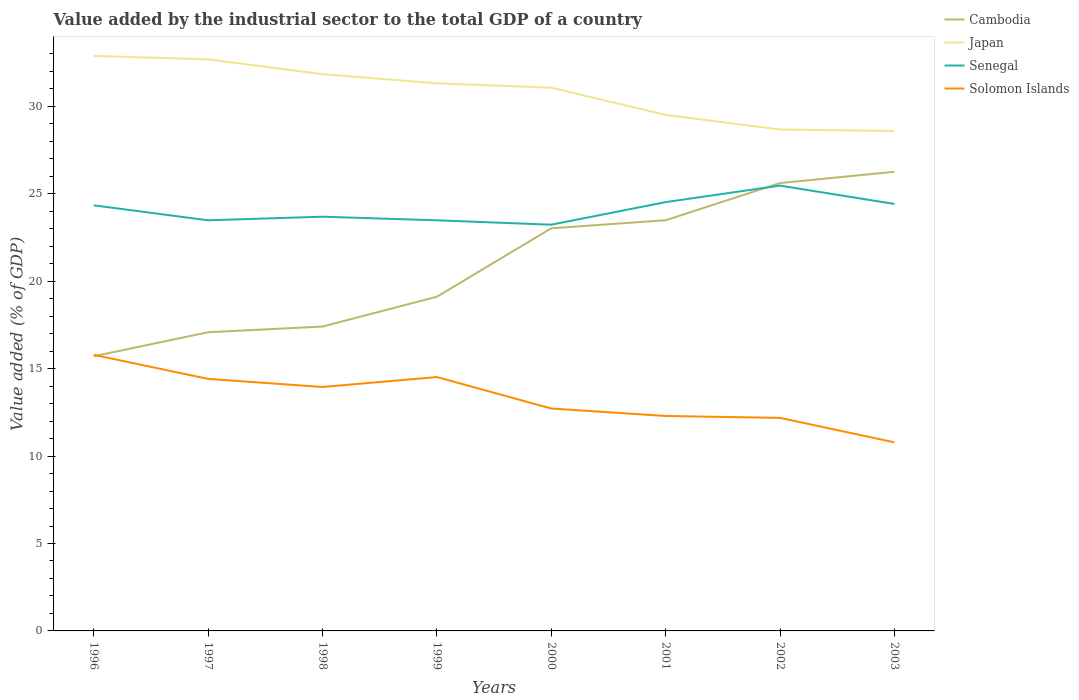How many different coloured lines are there?
Your answer should be very brief. 4. Across all years, what is the maximum value added by the industrial sector to the total GDP in Senegal?
Offer a very short reply. 23.23. In which year was the value added by the industrial sector to the total GDP in Solomon Islands maximum?
Ensure brevity in your answer.  2003. What is the total value added by the industrial sector to the total GDP in Senegal in the graph?
Offer a terse response. 0.25. What is the difference between the highest and the second highest value added by the industrial sector to the total GDP in Cambodia?
Provide a short and direct response. 10.55. Is the value added by the industrial sector to the total GDP in Solomon Islands strictly greater than the value added by the industrial sector to the total GDP in Cambodia over the years?
Offer a terse response. No. How many lines are there?
Your response must be concise. 4. How many years are there in the graph?
Keep it short and to the point. 8. Does the graph contain any zero values?
Provide a short and direct response. No. Does the graph contain grids?
Your response must be concise. No. Where does the legend appear in the graph?
Keep it short and to the point. Top right. How many legend labels are there?
Make the answer very short. 4. What is the title of the graph?
Provide a short and direct response. Value added by the industrial sector to the total GDP of a country. What is the label or title of the X-axis?
Your answer should be compact. Years. What is the label or title of the Y-axis?
Keep it short and to the point. Value added (% of GDP). What is the Value added (% of GDP) of Cambodia in 1996?
Provide a succinct answer. 15.71. What is the Value added (% of GDP) of Japan in 1996?
Your response must be concise. 32.88. What is the Value added (% of GDP) in Senegal in 1996?
Your answer should be very brief. 24.34. What is the Value added (% of GDP) in Solomon Islands in 1996?
Your answer should be compact. 15.79. What is the Value added (% of GDP) in Cambodia in 1997?
Provide a short and direct response. 17.08. What is the Value added (% of GDP) in Japan in 1997?
Your response must be concise. 32.69. What is the Value added (% of GDP) in Senegal in 1997?
Your answer should be compact. 23.48. What is the Value added (% of GDP) of Solomon Islands in 1997?
Give a very brief answer. 14.41. What is the Value added (% of GDP) of Cambodia in 1998?
Provide a short and direct response. 17.41. What is the Value added (% of GDP) of Japan in 1998?
Your answer should be very brief. 31.84. What is the Value added (% of GDP) of Senegal in 1998?
Offer a very short reply. 23.69. What is the Value added (% of GDP) in Solomon Islands in 1998?
Make the answer very short. 13.95. What is the Value added (% of GDP) in Cambodia in 1999?
Your response must be concise. 19.11. What is the Value added (% of GDP) in Japan in 1999?
Your answer should be compact. 31.32. What is the Value added (% of GDP) of Senegal in 1999?
Provide a short and direct response. 23.48. What is the Value added (% of GDP) of Solomon Islands in 1999?
Your response must be concise. 14.52. What is the Value added (% of GDP) of Cambodia in 2000?
Offer a very short reply. 23.03. What is the Value added (% of GDP) of Japan in 2000?
Your answer should be very brief. 31.06. What is the Value added (% of GDP) in Senegal in 2000?
Your answer should be compact. 23.23. What is the Value added (% of GDP) of Solomon Islands in 2000?
Your answer should be compact. 12.72. What is the Value added (% of GDP) in Cambodia in 2001?
Your response must be concise. 23.49. What is the Value added (% of GDP) of Japan in 2001?
Provide a short and direct response. 29.51. What is the Value added (% of GDP) of Senegal in 2001?
Ensure brevity in your answer.  24.52. What is the Value added (% of GDP) of Solomon Islands in 2001?
Provide a succinct answer. 12.29. What is the Value added (% of GDP) in Cambodia in 2002?
Make the answer very short. 25.61. What is the Value added (% of GDP) of Japan in 2002?
Your answer should be compact. 28.67. What is the Value added (% of GDP) of Senegal in 2002?
Keep it short and to the point. 25.47. What is the Value added (% of GDP) in Solomon Islands in 2002?
Provide a succinct answer. 12.18. What is the Value added (% of GDP) in Cambodia in 2003?
Make the answer very short. 26.26. What is the Value added (% of GDP) in Japan in 2003?
Give a very brief answer. 28.59. What is the Value added (% of GDP) in Senegal in 2003?
Your response must be concise. 24.42. What is the Value added (% of GDP) in Solomon Islands in 2003?
Your answer should be very brief. 10.78. Across all years, what is the maximum Value added (% of GDP) in Cambodia?
Provide a succinct answer. 26.26. Across all years, what is the maximum Value added (% of GDP) in Japan?
Give a very brief answer. 32.88. Across all years, what is the maximum Value added (% of GDP) in Senegal?
Your answer should be compact. 25.47. Across all years, what is the maximum Value added (% of GDP) in Solomon Islands?
Your response must be concise. 15.79. Across all years, what is the minimum Value added (% of GDP) in Cambodia?
Provide a succinct answer. 15.71. Across all years, what is the minimum Value added (% of GDP) in Japan?
Ensure brevity in your answer.  28.59. Across all years, what is the minimum Value added (% of GDP) of Senegal?
Ensure brevity in your answer.  23.23. Across all years, what is the minimum Value added (% of GDP) of Solomon Islands?
Give a very brief answer. 10.78. What is the total Value added (% of GDP) of Cambodia in the graph?
Provide a succinct answer. 167.69. What is the total Value added (% of GDP) in Japan in the graph?
Offer a very short reply. 246.57. What is the total Value added (% of GDP) of Senegal in the graph?
Provide a short and direct response. 192.63. What is the total Value added (% of GDP) in Solomon Islands in the graph?
Offer a very short reply. 106.65. What is the difference between the Value added (% of GDP) of Cambodia in 1996 and that in 1997?
Offer a very short reply. -1.38. What is the difference between the Value added (% of GDP) of Japan in 1996 and that in 1997?
Provide a succinct answer. 0.2. What is the difference between the Value added (% of GDP) of Senegal in 1996 and that in 1997?
Keep it short and to the point. 0.86. What is the difference between the Value added (% of GDP) in Solomon Islands in 1996 and that in 1997?
Make the answer very short. 1.37. What is the difference between the Value added (% of GDP) in Cambodia in 1996 and that in 1998?
Keep it short and to the point. -1.7. What is the difference between the Value added (% of GDP) in Japan in 1996 and that in 1998?
Offer a very short reply. 1.05. What is the difference between the Value added (% of GDP) in Senegal in 1996 and that in 1998?
Offer a very short reply. 0.65. What is the difference between the Value added (% of GDP) in Solomon Islands in 1996 and that in 1998?
Offer a very short reply. 1.84. What is the difference between the Value added (% of GDP) of Cambodia in 1996 and that in 1999?
Provide a short and direct response. -3.41. What is the difference between the Value added (% of GDP) in Japan in 1996 and that in 1999?
Provide a succinct answer. 1.57. What is the difference between the Value added (% of GDP) in Senegal in 1996 and that in 1999?
Offer a very short reply. 0.86. What is the difference between the Value added (% of GDP) of Solomon Islands in 1996 and that in 1999?
Offer a terse response. 1.27. What is the difference between the Value added (% of GDP) in Cambodia in 1996 and that in 2000?
Offer a terse response. -7.32. What is the difference between the Value added (% of GDP) of Japan in 1996 and that in 2000?
Offer a very short reply. 1.82. What is the difference between the Value added (% of GDP) in Senegal in 1996 and that in 2000?
Your response must be concise. 1.11. What is the difference between the Value added (% of GDP) of Solomon Islands in 1996 and that in 2000?
Offer a very short reply. 3.07. What is the difference between the Value added (% of GDP) in Cambodia in 1996 and that in 2001?
Give a very brief answer. -7.78. What is the difference between the Value added (% of GDP) in Japan in 1996 and that in 2001?
Your answer should be compact. 3.37. What is the difference between the Value added (% of GDP) in Senegal in 1996 and that in 2001?
Provide a short and direct response. -0.18. What is the difference between the Value added (% of GDP) of Solomon Islands in 1996 and that in 2001?
Your response must be concise. 3.49. What is the difference between the Value added (% of GDP) in Cambodia in 1996 and that in 2002?
Give a very brief answer. -9.91. What is the difference between the Value added (% of GDP) in Japan in 1996 and that in 2002?
Make the answer very short. 4.21. What is the difference between the Value added (% of GDP) in Senegal in 1996 and that in 2002?
Offer a terse response. -1.13. What is the difference between the Value added (% of GDP) in Solomon Islands in 1996 and that in 2002?
Ensure brevity in your answer.  3.6. What is the difference between the Value added (% of GDP) of Cambodia in 1996 and that in 2003?
Your answer should be compact. -10.55. What is the difference between the Value added (% of GDP) in Japan in 1996 and that in 2003?
Your answer should be compact. 4.3. What is the difference between the Value added (% of GDP) of Senegal in 1996 and that in 2003?
Provide a succinct answer. -0.08. What is the difference between the Value added (% of GDP) of Solomon Islands in 1996 and that in 2003?
Your response must be concise. 5. What is the difference between the Value added (% of GDP) in Cambodia in 1997 and that in 1998?
Offer a terse response. -0.32. What is the difference between the Value added (% of GDP) of Japan in 1997 and that in 1998?
Your answer should be very brief. 0.85. What is the difference between the Value added (% of GDP) of Senegal in 1997 and that in 1998?
Ensure brevity in your answer.  -0.21. What is the difference between the Value added (% of GDP) in Solomon Islands in 1997 and that in 1998?
Provide a short and direct response. 0.46. What is the difference between the Value added (% of GDP) of Cambodia in 1997 and that in 1999?
Give a very brief answer. -2.03. What is the difference between the Value added (% of GDP) of Japan in 1997 and that in 1999?
Give a very brief answer. 1.37. What is the difference between the Value added (% of GDP) of Senegal in 1997 and that in 1999?
Offer a very short reply. 0. What is the difference between the Value added (% of GDP) of Solomon Islands in 1997 and that in 1999?
Provide a short and direct response. -0.11. What is the difference between the Value added (% of GDP) in Cambodia in 1997 and that in 2000?
Provide a succinct answer. -5.94. What is the difference between the Value added (% of GDP) in Japan in 1997 and that in 2000?
Your answer should be very brief. 1.62. What is the difference between the Value added (% of GDP) of Senegal in 1997 and that in 2000?
Provide a succinct answer. 0.25. What is the difference between the Value added (% of GDP) in Solomon Islands in 1997 and that in 2000?
Keep it short and to the point. 1.7. What is the difference between the Value added (% of GDP) of Cambodia in 1997 and that in 2001?
Provide a succinct answer. -6.4. What is the difference between the Value added (% of GDP) of Japan in 1997 and that in 2001?
Provide a short and direct response. 3.18. What is the difference between the Value added (% of GDP) in Senegal in 1997 and that in 2001?
Your response must be concise. -1.04. What is the difference between the Value added (% of GDP) in Solomon Islands in 1997 and that in 2001?
Provide a succinct answer. 2.12. What is the difference between the Value added (% of GDP) in Cambodia in 1997 and that in 2002?
Keep it short and to the point. -8.53. What is the difference between the Value added (% of GDP) of Japan in 1997 and that in 2002?
Provide a short and direct response. 4.01. What is the difference between the Value added (% of GDP) in Senegal in 1997 and that in 2002?
Offer a terse response. -1.98. What is the difference between the Value added (% of GDP) in Solomon Islands in 1997 and that in 2002?
Your answer should be compact. 2.23. What is the difference between the Value added (% of GDP) in Cambodia in 1997 and that in 2003?
Provide a succinct answer. -9.18. What is the difference between the Value added (% of GDP) of Japan in 1997 and that in 2003?
Your response must be concise. 4.1. What is the difference between the Value added (% of GDP) of Senegal in 1997 and that in 2003?
Give a very brief answer. -0.93. What is the difference between the Value added (% of GDP) in Solomon Islands in 1997 and that in 2003?
Provide a succinct answer. 3.63. What is the difference between the Value added (% of GDP) of Cambodia in 1998 and that in 1999?
Keep it short and to the point. -1.71. What is the difference between the Value added (% of GDP) in Japan in 1998 and that in 1999?
Your answer should be very brief. 0.52. What is the difference between the Value added (% of GDP) of Senegal in 1998 and that in 1999?
Make the answer very short. 0.21. What is the difference between the Value added (% of GDP) in Solomon Islands in 1998 and that in 1999?
Give a very brief answer. -0.57. What is the difference between the Value added (% of GDP) in Cambodia in 1998 and that in 2000?
Offer a very short reply. -5.62. What is the difference between the Value added (% of GDP) of Japan in 1998 and that in 2000?
Offer a terse response. 0.77. What is the difference between the Value added (% of GDP) of Senegal in 1998 and that in 2000?
Provide a succinct answer. 0.46. What is the difference between the Value added (% of GDP) of Solomon Islands in 1998 and that in 2000?
Your response must be concise. 1.23. What is the difference between the Value added (% of GDP) in Cambodia in 1998 and that in 2001?
Make the answer very short. -6.08. What is the difference between the Value added (% of GDP) in Japan in 1998 and that in 2001?
Keep it short and to the point. 2.33. What is the difference between the Value added (% of GDP) in Senegal in 1998 and that in 2001?
Your answer should be very brief. -0.83. What is the difference between the Value added (% of GDP) in Solomon Islands in 1998 and that in 2001?
Make the answer very short. 1.66. What is the difference between the Value added (% of GDP) of Cambodia in 1998 and that in 2002?
Your response must be concise. -8.21. What is the difference between the Value added (% of GDP) of Japan in 1998 and that in 2002?
Your response must be concise. 3.17. What is the difference between the Value added (% of GDP) of Senegal in 1998 and that in 2002?
Your response must be concise. -1.78. What is the difference between the Value added (% of GDP) of Solomon Islands in 1998 and that in 2002?
Your answer should be compact. 1.77. What is the difference between the Value added (% of GDP) of Cambodia in 1998 and that in 2003?
Provide a short and direct response. -8.85. What is the difference between the Value added (% of GDP) of Japan in 1998 and that in 2003?
Make the answer very short. 3.25. What is the difference between the Value added (% of GDP) of Senegal in 1998 and that in 2003?
Your response must be concise. -0.73. What is the difference between the Value added (% of GDP) of Solomon Islands in 1998 and that in 2003?
Provide a short and direct response. 3.17. What is the difference between the Value added (% of GDP) of Cambodia in 1999 and that in 2000?
Your answer should be very brief. -3.91. What is the difference between the Value added (% of GDP) of Japan in 1999 and that in 2000?
Keep it short and to the point. 0.25. What is the difference between the Value added (% of GDP) in Senegal in 1999 and that in 2000?
Offer a terse response. 0.25. What is the difference between the Value added (% of GDP) of Solomon Islands in 1999 and that in 2000?
Make the answer very short. 1.8. What is the difference between the Value added (% of GDP) of Cambodia in 1999 and that in 2001?
Your response must be concise. -4.37. What is the difference between the Value added (% of GDP) in Japan in 1999 and that in 2001?
Provide a short and direct response. 1.81. What is the difference between the Value added (% of GDP) in Senegal in 1999 and that in 2001?
Provide a succinct answer. -1.04. What is the difference between the Value added (% of GDP) of Solomon Islands in 1999 and that in 2001?
Provide a short and direct response. 2.23. What is the difference between the Value added (% of GDP) in Cambodia in 1999 and that in 2002?
Offer a terse response. -6.5. What is the difference between the Value added (% of GDP) of Japan in 1999 and that in 2002?
Make the answer very short. 2.64. What is the difference between the Value added (% of GDP) in Senegal in 1999 and that in 2002?
Make the answer very short. -1.99. What is the difference between the Value added (% of GDP) in Solomon Islands in 1999 and that in 2002?
Your response must be concise. 2.33. What is the difference between the Value added (% of GDP) in Cambodia in 1999 and that in 2003?
Your answer should be very brief. -7.15. What is the difference between the Value added (% of GDP) in Japan in 1999 and that in 2003?
Your answer should be very brief. 2.73. What is the difference between the Value added (% of GDP) of Senegal in 1999 and that in 2003?
Offer a terse response. -0.93. What is the difference between the Value added (% of GDP) of Solomon Islands in 1999 and that in 2003?
Provide a short and direct response. 3.74. What is the difference between the Value added (% of GDP) in Cambodia in 2000 and that in 2001?
Your response must be concise. -0.46. What is the difference between the Value added (% of GDP) in Japan in 2000 and that in 2001?
Provide a succinct answer. 1.55. What is the difference between the Value added (% of GDP) of Senegal in 2000 and that in 2001?
Your response must be concise. -1.29. What is the difference between the Value added (% of GDP) in Solomon Islands in 2000 and that in 2001?
Your answer should be compact. 0.42. What is the difference between the Value added (% of GDP) in Cambodia in 2000 and that in 2002?
Make the answer very short. -2.59. What is the difference between the Value added (% of GDP) in Japan in 2000 and that in 2002?
Provide a succinct answer. 2.39. What is the difference between the Value added (% of GDP) in Senegal in 2000 and that in 2002?
Give a very brief answer. -2.24. What is the difference between the Value added (% of GDP) of Solomon Islands in 2000 and that in 2002?
Keep it short and to the point. 0.53. What is the difference between the Value added (% of GDP) in Cambodia in 2000 and that in 2003?
Your answer should be very brief. -3.23. What is the difference between the Value added (% of GDP) in Japan in 2000 and that in 2003?
Offer a terse response. 2.48. What is the difference between the Value added (% of GDP) of Senegal in 2000 and that in 2003?
Provide a succinct answer. -1.18. What is the difference between the Value added (% of GDP) in Solomon Islands in 2000 and that in 2003?
Your response must be concise. 1.93. What is the difference between the Value added (% of GDP) in Cambodia in 2001 and that in 2002?
Ensure brevity in your answer.  -2.13. What is the difference between the Value added (% of GDP) of Japan in 2001 and that in 2002?
Make the answer very short. 0.84. What is the difference between the Value added (% of GDP) of Senegal in 2001 and that in 2002?
Keep it short and to the point. -0.94. What is the difference between the Value added (% of GDP) of Solomon Islands in 2001 and that in 2002?
Provide a short and direct response. 0.11. What is the difference between the Value added (% of GDP) of Cambodia in 2001 and that in 2003?
Ensure brevity in your answer.  -2.77. What is the difference between the Value added (% of GDP) in Japan in 2001 and that in 2003?
Offer a terse response. 0.92. What is the difference between the Value added (% of GDP) of Senegal in 2001 and that in 2003?
Make the answer very short. 0.11. What is the difference between the Value added (% of GDP) in Solomon Islands in 2001 and that in 2003?
Your response must be concise. 1.51. What is the difference between the Value added (% of GDP) in Cambodia in 2002 and that in 2003?
Your response must be concise. -0.65. What is the difference between the Value added (% of GDP) in Japan in 2002 and that in 2003?
Offer a terse response. 0.08. What is the difference between the Value added (% of GDP) of Senegal in 2002 and that in 2003?
Provide a short and direct response. 1.05. What is the difference between the Value added (% of GDP) of Solomon Islands in 2002 and that in 2003?
Make the answer very short. 1.4. What is the difference between the Value added (% of GDP) in Cambodia in 1996 and the Value added (% of GDP) in Japan in 1997?
Your answer should be very brief. -16.98. What is the difference between the Value added (% of GDP) of Cambodia in 1996 and the Value added (% of GDP) of Senegal in 1997?
Give a very brief answer. -7.78. What is the difference between the Value added (% of GDP) of Cambodia in 1996 and the Value added (% of GDP) of Solomon Islands in 1997?
Your response must be concise. 1.29. What is the difference between the Value added (% of GDP) in Japan in 1996 and the Value added (% of GDP) in Senegal in 1997?
Give a very brief answer. 9.4. What is the difference between the Value added (% of GDP) of Japan in 1996 and the Value added (% of GDP) of Solomon Islands in 1997?
Offer a very short reply. 18.47. What is the difference between the Value added (% of GDP) of Senegal in 1996 and the Value added (% of GDP) of Solomon Islands in 1997?
Provide a short and direct response. 9.93. What is the difference between the Value added (% of GDP) in Cambodia in 1996 and the Value added (% of GDP) in Japan in 1998?
Offer a very short reply. -16.13. What is the difference between the Value added (% of GDP) of Cambodia in 1996 and the Value added (% of GDP) of Senegal in 1998?
Your answer should be compact. -7.98. What is the difference between the Value added (% of GDP) of Cambodia in 1996 and the Value added (% of GDP) of Solomon Islands in 1998?
Provide a short and direct response. 1.76. What is the difference between the Value added (% of GDP) of Japan in 1996 and the Value added (% of GDP) of Senegal in 1998?
Provide a short and direct response. 9.2. What is the difference between the Value added (% of GDP) in Japan in 1996 and the Value added (% of GDP) in Solomon Islands in 1998?
Offer a terse response. 18.93. What is the difference between the Value added (% of GDP) of Senegal in 1996 and the Value added (% of GDP) of Solomon Islands in 1998?
Give a very brief answer. 10.39. What is the difference between the Value added (% of GDP) in Cambodia in 1996 and the Value added (% of GDP) in Japan in 1999?
Your answer should be very brief. -15.61. What is the difference between the Value added (% of GDP) in Cambodia in 1996 and the Value added (% of GDP) in Senegal in 1999?
Make the answer very short. -7.78. What is the difference between the Value added (% of GDP) in Cambodia in 1996 and the Value added (% of GDP) in Solomon Islands in 1999?
Ensure brevity in your answer.  1.19. What is the difference between the Value added (% of GDP) of Japan in 1996 and the Value added (% of GDP) of Senegal in 1999?
Your answer should be compact. 9.4. What is the difference between the Value added (% of GDP) of Japan in 1996 and the Value added (% of GDP) of Solomon Islands in 1999?
Provide a succinct answer. 18.37. What is the difference between the Value added (% of GDP) of Senegal in 1996 and the Value added (% of GDP) of Solomon Islands in 1999?
Offer a very short reply. 9.82. What is the difference between the Value added (% of GDP) of Cambodia in 1996 and the Value added (% of GDP) of Japan in 2000?
Keep it short and to the point. -15.36. What is the difference between the Value added (% of GDP) in Cambodia in 1996 and the Value added (% of GDP) in Senegal in 2000?
Your answer should be compact. -7.53. What is the difference between the Value added (% of GDP) of Cambodia in 1996 and the Value added (% of GDP) of Solomon Islands in 2000?
Offer a terse response. 2.99. What is the difference between the Value added (% of GDP) of Japan in 1996 and the Value added (% of GDP) of Senegal in 2000?
Ensure brevity in your answer.  9.65. What is the difference between the Value added (% of GDP) of Japan in 1996 and the Value added (% of GDP) of Solomon Islands in 2000?
Provide a short and direct response. 20.17. What is the difference between the Value added (% of GDP) in Senegal in 1996 and the Value added (% of GDP) in Solomon Islands in 2000?
Your response must be concise. 11.62. What is the difference between the Value added (% of GDP) in Cambodia in 1996 and the Value added (% of GDP) in Japan in 2001?
Offer a terse response. -13.8. What is the difference between the Value added (% of GDP) in Cambodia in 1996 and the Value added (% of GDP) in Senegal in 2001?
Provide a short and direct response. -8.82. What is the difference between the Value added (% of GDP) of Cambodia in 1996 and the Value added (% of GDP) of Solomon Islands in 2001?
Make the answer very short. 3.41. What is the difference between the Value added (% of GDP) of Japan in 1996 and the Value added (% of GDP) of Senegal in 2001?
Ensure brevity in your answer.  8.36. What is the difference between the Value added (% of GDP) in Japan in 1996 and the Value added (% of GDP) in Solomon Islands in 2001?
Make the answer very short. 20.59. What is the difference between the Value added (% of GDP) of Senegal in 1996 and the Value added (% of GDP) of Solomon Islands in 2001?
Ensure brevity in your answer.  12.05. What is the difference between the Value added (% of GDP) in Cambodia in 1996 and the Value added (% of GDP) in Japan in 2002?
Give a very brief answer. -12.97. What is the difference between the Value added (% of GDP) of Cambodia in 1996 and the Value added (% of GDP) of Senegal in 2002?
Make the answer very short. -9.76. What is the difference between the Value added (% of GDP) of Cambodia in 1996 and the Value added (% of GDP) of Solomon Islands in 2002?
Provide a short and direct response. 3.52. What is the difference between the Value added (% of GDP) in Japan in 1996 and the Value added (% of GDP) in Senegal in 2002?
Provide a succinct answer. 7.42. What is the difference between the Value added (% of GDP) in Japan in 1996 and the Value added (% of GDP) in Solomon Islands in 2002?
Provide a succinct answer. 20.7. What is the difference between the Value added (% of GDP) of Senegal in 1996 and the Value added (% of GDP) of Solomon Islands in 2002?
Provide a succinct answer. 12.16. What is the difference between the Value added (% of GDP) in Cambodia in 1996 and the Value added (% of GDP) in Japan in 2003?
Give a very brief answer. -12.88. What is the difference between the Value added (% of GDP) of Cambodia in 1996 and the Value added (% of GDP) of Senegal in 2003?
Make the answer very short. -8.71. What is the difference between the Value added (% of GDP) in Cambodia in 1996 and the Value added (% of GDP) in Solomon Islands in 2003?
Make the answer very short. 4.92. What is the difference between the Value added (% of GDP) in Japan in 1996 and the Value added (% of GDP) in Senegal in 2003?
Provide a short and direct response. 8.47. What is the difference between the Value added (% of GDP) of Japan in 1996 and the Value added (% of GDP) of Solomon Islands in 2003?
Your answer should be very brief. 22.1. What is the difference between the Value added (% of GDP) in Senegal in 1996 and the Value added (% of GDP) in Solomon Islands in 2003?
Make the answer very short. 13.56. What is the difference between the Value added (% of GDP) in Cambodia in 1997 and the Value added (% of GDP) in Japan in 1998?
Your answer should be very brief. -14.76. What is the difference between the Value added (% of GDP) in Cambodia in 1997 and the Value added (% of GDP) in Senegal in 1998?
Your response must be concise. -6.61. What is the difference between the Value added (% of GDP) in Cambodia in 1997 and the Value added (% of GDP) in Solomon Islands in 1998?
Offer a terse response. 3.13. What is the difference between the Value added (% of GDP) of Japan in 1997 and the Value added (% of GDP) of Senegal in 1998?
Provide a succinct answer. 9. What is the difference between the Value added (% of GDP) in Japan in 1997 and the Value added (% of GDP) in Solomon Islands in 1998?
Your answer should be very brief. 18.74. What is the difference between the Value added (% of GDP) in Senegal in 1997 and the Value added (% of GDP) in Solomon Islands in 1998?
Keep it short and to the point. 9.53. What is the difference between the Value added (% of GDP) of Cambodia in 1997 and the Value added (% of GDP) of Japan in 1999?
Your answer should be compact. -14.24. What is the difference between the Value added (% of GDP) in Cambodia in 1997 and the Value added (% of GDP) in Senegal in 1999?
Keep it short and to the point. -6.4. What is the difference between the Value added (% of GDP) in Cambodia in 1997 and the Value added (% of GDP) in Solomon Islands in 1999?
Offer a very short reply. 2.56. What is the difference between the Value added (% of GDP) in Japan in 1997 and the Value added (% of GDP) in Senegal in 1999?
Your response must be concise. 9.21. What is the difference between the Value added (% of GDP) in Japan in 1997 and the Value added (% of GDP) in Solomon Islands in 1999?
Keep it short and to the point. 18.17. What is the difference between the Value added (% of GDP) in Senegal in 1997 and the Value added (% of GDP) in Solomon Islands in 1999?
Ensure brevity in your answer.  8.96. What is the difference between the Value added (% of GDP) in Cambodia in 1997 and the Value added (% of GDP) in Japan in 2000?
Give a very brief answer. -13.98. What is the difference between the Value added (% of GDP) of Cambodia in 1997 and the Value added (% of GDP) of Senegal in 2000?
Make the answer very short. -6.15. What is the difference between the Value added (% of GDP) in Cambodia in 1997 and the Value added (% of GDP) in Solomon Islands in 2000?
Give a very brief answer. 4.36. What is the difference between the Value added (% of GDP) of Japan in 1997 and the Value added (% of GDP) of Senegal in 2000?
Offer a very short reply. 9.46. What is the difference between the Value added (% of GDP) in Japan in 1997 and the Value added (% of GDP) in Solomon Islands in 2000?
Your answer should be compact. 19.97. What is the difference between the Value added (% of GDP) of Senegal in 1997 and the Value added (% of GDP) of Solomon Islands in 2000?
Give a very brief answer. 10.76. What is the difference between the Value added (% of GDP) in Cambodia in 1997 and the Value added (% of GDP) in Japan in 2001?
Offer a terse response. -12.43. What is the difference between the Value added (% of GDP) in Cambodia in 1997 and the Value added (% of GDP) in Senegal in 2001?
Provide a short and direct response. -7.44. What is the difference between the Value added (% of GDP) in Cambodia in 1997 and the Value added (% of GDP) in Solomon Islands in 2001?
Your answer should be compact. 4.79. What is the difference between the Value added (% of GDP) of Japan in 1997 and the Value added (% of GDP) of Senegal in 2001?
Your response must be concise. 8.16. What is the difference between the Value added (% of GDP) of Japan in 1997 and the Value added (% of GDP) of Solomon Islands in 2001?
Ensure brevity in your answer.  20.39. What is the difference between the Value added (% of GDP) of Senegal in 1997 and the Value added (% of GDP) of Solomon Islands in 2001?
Ensure brevity in your answer.  11.19. What is the difference between the Value added (% of GDP) in Cambodia in 1997 and the Value added (% of GDP) in Japan in 2002?
Make the answer very short. -11.59. What is the difference between the Value added (% of GDP) in Cambodia in 1997 and the Value added (% of GDP) in Senegal in 2002?
Your answer should be compact. -8.38. What is the difference between the Value added (% of GDP) in Cambodia in 1997 and the Value added (% of GDP) in Solomon Islands in 2002?
Your response must be concise. 4.9. What is the difference between the Value added (% of GDP) of Japan in 1997 and the Value added (% of GDP) of Senegal in 2002?
Ensure brevity in your answer.  7.22. What is the difference between the Value added (% of GDP) of Japan in 1997 and the Value added (% of GDP) of Solomon Islands in 2002?
Keep it short and to the point. 20.5. What is the difference between the Value added (% of GDP) of Senegal in 1997 and the Value added (% of GDP) of Solomon Islands in 2002?
Your answer should be compact. 11.3. What is the difference between the Value added (% of GDP) in Cambodia in 1997 and the Value added (% of GDP) in Japan in 2003?
Your answer should be compact. -11.51. What is the difference between the Value added (% of GDP) of Cambodia in 1997 and the Value added (% of GDP) of Senegal in 2003?
Give a very brief answer. -7.33. What is the difference between the Value added (% of GDP) of Cambodia in 1997 and the Value added (% of GDP) of Solomon Islands in 2003?
Provide a succinct answer. 6.3. What is the difference between the Value added (% of GDP) in Japan in 1997 and the Value added (% of GDP) in Senegal in 2003?
Provide a short and direct response. 8.27. What is the difference between the Value added (% of GDP) of Japan in 1997 and the Value added (% of GDP) of Solomon Islands in 2003?
Provide a succinct answer. 21.9. What is the difference between the Value added (% of GDP) in Senegal in 1997 and the Value added (% of GDP) in Solomon Islands in 2003?
Offer a very short reply. 12.7. What is the difference between the Value added (% of GDP) in Cambodia in 1998 and the Value added (% of GDP) in Japan in 1999?
Your answer should be compact. -13.91. What is the difference between the Value added (% of GDP) in Cambodia in 1998 and the Value added (% of GDP) in Senegal in 1999?
Make the answer very short. -6.08. What is the difference between the Value added (% of GDP) of Cambodia in 1998 and the Value added (% of GDP) of Solomon Islands in 1999?
Make the answer very short. 2.89. What is the difference between the Value added (% of GDP) in Japan in 1998 and the Value added (% of GDP) in Senegal in 1999?
Keep it short and to the point. 8.36. What is the difference between the Value added (% of GDP) of Japan in 1998 and the Value added (% of GDP) of Solomon Islands in 1999?
Your answer should be very brief. 17.32. What is the difference between the Value added (% of GDP) of Senegal in 1998 and the Value added (% of GDP) of Solomon Islands in 1999?
Offer a very short reply. 9.17. What is the difference between the Value added (% of GDP) in Cambodia in 1998 and the Value added (% of GDP) in Japan in 2000?
Your answer should be very brief. -13.66. What is the difference between the Value added (% of GDP) of Cambodia in 1998 and the Value added (% of GDP) of Senegal in 2000?
Your answer should be compact. -5.83. What is the difference between the Value added (% of GDP) in Cambodia in 1998 and the Value added (% of GDP) in Solomon Islands in 2000?
Provide a succinct answer. 4.69. What is the difference between the Value added (% of GDP) in Japan in 1998 and the Value added (% of GDP) in Senegal in 2000?
Your answer should be compact. 8.61. What is the difference between the Value added (% of GDP) in Japan in 1998 and the Value added (% of GDP) in Solomon Islands in 2000?
Provide a succinct answer. 19.12. What is the difference between the Value added (% of GDP) of Senegal in 1998 and the Value added (% of GDP) of Solomon Islands in 2000?
Ensure brevity in your answer.  10.97. What is the difference between the Value added (% of GDP) of Cambodia in 1998 and the Value added (% of GDP) of Japan in 2001?
Your answer should be very brief. -12.1. What is the difference between the Value added (% of GDP) of Cambodia in 1998 and the Value added (% of GDP) of Senegal in 2001?
Ensure brevity in your answer.  -7.12. What is the difference between the Value added (% of GDP) of Cambodia in 1998 and the Value added (% of GDP) of Solomon Islands in 2001?
Offer a very short reply. 5.11. What is the difference between the Value added (% of GDP) in Japan in 1998 and the Value added (% of GDP) in Senegal in 2001?
Keep it short and to the point. 7.32. What is the difference between the Value added (% of GDP) of Japan in 1998 and the Value added (% of GDP) of Solomon Islands in 2001?
Your answer should be very brief. 19.55. What is the difference between the Value added (% of GDP) of Senegal in 1998 and the Value added (% of GDP) of Solomon Islands in 2001?
Your answer should be very brief. 11.4. What is the difference between the Value added (% of GDP) in Cambodia in 1998 and the Value added (% of GDP) in Japan in 2002?
Your answer should be compact. -11.27. What is the difference between the Value added (% of GDP) in Cambodia in 1998 and the Value added (% of GDP) in Senegal in 2002?
Provide a short and direct response. -8.06. What is the difference between the Value added (% of GDP) in Cambodia in 1998 and the Value added (% of GDP) in Solomon Islands in 2002?
Your answer should be very brief. 5.22. What is the difference between the Value added (% of GDP) in Japan in 1998 and the Value added (% of GDP) in Senegal in 2002?
Your response must be concise. 6.37. What is the difference between the Value added (% of GDP) in Japan in 1998 and the Value added (% of GDP) in Solomon Islands in 2002?
Offer a terse response. 19.66. What is the difference between the Value added (% of GDP) in Senegal in 1998 and the Value added (% of GDP) in Solomon Islands in 2002?
Give a very brief answer. 11.5. What is the difference between the Value added (% of GDP) in Cambodia in 1998 and the Value added (% of GDP) in Japan in 2003?
Ensure brevity in your answer.  -11.18. What is the difference between the Value added (% of GDP) of Cambodia in 1998 and the Value added (% of GDP) of Senegal in 2003?
Offer a terse response. -7.01. What is the difference between the Value added (% of GDP) of Cambodia in 1998 and the Value added (% of GDP) of Solomon Islands in 2003?
Offer a terse response. 6.62. What is the difference between the Value added (% of GDP) in Japan in 1998 and the Value added (% of GDP) in Senegal in 2003?
Give a very brief answer. 7.42. What is the difference between the Value added (% of GDP) in Japan in 1998 and the Value added (% of GDP) in Solomon Islands in 2003?
Your response must be concise. 21.06. What is the difference between the Value added (% of GDP) in Senegal in 1998 and the Value added (% of GDP) in Solomon Islands in 2003?
Ensure brevity in your answer.  12.9. What is the difference between the Value added (% of GDP) of Cambodia in 1999 and the Value added (% of GDP) of Japan in 2000?
Make the answer very short. -11.95. What is the difference between the Value added (% of GDP) in Cambodia in 1999 and the Value added (% of GDP) in Senegal in 2000?
Ensure brevity in your answer.  -4.12. What is the difference between the Value added (% of GDP) of Cambodia in 1999 and the Value added (% of GDP) of Solomon Islands in 2000?
Offer a terse response. 6.39. What is the difference between the Value added (% of GDP) in Japan in 1999 and the Value added (% of GDP) in Senegal in 2000?
Provide a succinct answer. 8.09. What is the difference between the Value added (% of GDP) in Japan in 1999 and the Value added (% of GDP) in Solomon Islands in 2000?
Keep it short and to the point. 18.6. What is the difference between the Value added (% of GDP) of Senegal in 1999 and the Value added (% of GDP) of Solomon Islands in 2000?
Provide a succinct answer. 10.76. What is the difference between the Value added (% of GDP) of Cambodia in 1999 and the Value added (% of GDP) of Japan in 2001?
Your answer should be compact. -10.4. What is the difference between the Value added (% of GDP) in Cambodia in 1999 and the Value added (% of GDP) in Senegal in 2001?
Your response must be concise. -5.41. What is the difference between the Value added (% of GDP) of Cambodia in 1999 and the Value added (% of GDP) of Solomon Islands in 2001?
Ensure brevity in your answer.  6.82. What is the difference between the Value added (% of GDP) of Japan in 1999 and the Value added (% of GDP) of Senegal in 2001?
Your response must be concise. 6.8. What is the difference between the Value added (% of GDP) of Japan in 1999 and the Value added (% of GDP) of Solomon Islands in 2001?
Offer a very short reply. 19.03. What is the difference between the Value added (% of GDP) in Senegal in 1999 and the Value added (% of GDP) in Solomon Islands in 2001?
Keep it short and to the point. 11.19. What is the difference between the Value added (% of GDP) in Cambodia in 1999 and the Value added (% of GDP) in Japan in 2002?
Your answer should be very brief. -9.56. What is the difference between the Value added (% of GDP) of Cambodia in 1999 and the Value added (% of GDP) of Senegal in 2002?
Your answer should be very brief. -6.35. What is the difference between the Value added (% of GDP) of Cambodia in 1999 and the Value added (% of GDP) of Solomon Islands in 2002?
Your answer should be very brief. 6.93. What is the difference between the Value added (% of GDP) in Japan in 1999 and the Value added (% of GDP) in Senegal in 2002?
Offer a terse response. 5.85. What is the difference between the Value added (% of GDP) in Japan in 1999 and the Value added (% of GDP) in Solomon Islands in 2002?
Provide a short and direct response. 19.13. What is the difference between the Value added (% of GDP) of Senegal in 1999 and the Value added (% of GDP) of Solomon Islands in 2002?
Your response must be concise. 11.3. What is the difference between the Value added (% of GDP) of Cambodia in 1999 and the Value added (% of GDP) of Japan in 2003?
Your response must be concise. -9.48. What is the difference between the Value added (% of GDP) of Cambodia in 1999 and the Value added (% of GDP) of Senegal in 2003?
Keep it short and to the point. -5.3. What is the difference between the Value added (% of GDP) in Cambodia in 1999 and the Value added (% of GDP) in Solomon Islands in 2003?
Your answer should be very brief. 8.33. What is the difference between the Value added (% of GDP) in Japan in 1999 and the Value added (% of GDP) in Senegal in 2003?
Give a very brief answer. 6.9. What is the difference between the Value added (% of GDP) of Japan in 1999 and the Value added (% of GDP) of Solomon Islands in 2003?
Offer a terse response. 20.53. What is the difference between the Value added (% of GDP) of Senegal in 1999 and the Value added (% of GDP) of Solomon Islands in 2003?
Provide a short and direct response. 12.7. What is the difference between the Value added (% of GDP) in Cambodia in 2000 and the Value added (% of GDP) in Japan in 2001?
Keep it short and to the point. -6.48. What is the difference between the Value added (% of GDP) in Cambodia in 2000 and the Value added (% of GDP) in Senegal in 2001?
Offer a terse response. -1.5. What is the difference between the Value added (% of GDP) in Cambodia in 2000 and the Value added (% of GDP) in Solomon Islands in 2001?
Your answer should be very brief. 10.73. What is the difference between the Value added (% of GDP) of Japan in 2000 and the Value added (% of GDP) of Senegal in 2001?
Offer a terse response. 6.54. What is the difference between the Value added (% of GDP) of Japan in 2000 and the Value added (% of GDP) of Solomon Islands in 2001?
Give a very brief answer. 18.77. What is the difference between the Value added (% of GDP) in Senegal in 2000 and the Value added (% of GDP) in Solomon Islands in 2001?
Make the answer very short. 10.94. What is the difference between the Value added (% of GDP) in Cambodia in 2000 and the Value added (% of GDP) in Japan in 2002?
Provide a succinct answer. -5.65. What is the difference between the Value added (% of GDP) of Cambodia in 2000 and the Value added (% of GDP) of Senegal in 2002?
Your response must be concise. -2.44. What is the difference between the Value added (% of GDP) of Cambodia in 2000 and the Value added (% of GDP) of Solomon Islands in 2002?
Your answer should be very brief. 10.84. What is the difference between the Value added (% of GDP) in Japan in 2000 and the Value added (% of GDP) in Senegal in 2002?
Keep it short and to the point. 5.6. What is the difference between the Value added (% of GDP) of Japan in 2000 and the Value added (% of GDP) of Solomon Islands in 2002?
Provide a short and direct response. 18.88. What is the difference between the Value added (% of GDP) of Senegal in 2000 and the Value added (% of GDP) of Solomon Islands in 2002?
Offer a very short reply. 11.05. What is the difference between the Value added (% of GDP) in Cambodia in 2000 and the Value added (% of GDP) in Japan in 2003?
Provide a succinct answer. -5.56. What is the difference between the Value added (% of GDP) of Cambodia in 2000 and the Value added (% of GDP) of Senegal in 2003?
Give a very brief answer. -1.39. What is the difference between the Value added (% of GDP) in Cambodia in 2000 and the Value added (% of GDP) in Solomon Islands in 2003?
Your response must be concise. 12.24. What is the difference between the Value added (% of GDP) of Japan in 2000 and the Value added (% of GDP) of Senegal in 2003?
Ensure brevity in your answer.  6.65. What is the difference between the Value added (% of GDP) in Japan in 2000 and the Value added (% of GDP) in Solomon Islands in 2003?
Offer a very short reply. 20.28. What is the difference between the Value added (% of GDP) of Senegal in 2000 and the Value added (% of GDP) of Solomon Islands in 2003?
Provide a short and direct response. 12.45. What is the difference between the Value added (% of GDP) of Cambodia in 2001 and the Value added (% of GDP) of Japan in 2002?
Your answer should be very brief. -5.19. What is the difference between the Value added (% of GDP) in Cambodia in 2001 and the Value added (% of GDP) in Senegal in 2002?
Your answer should be compact. -1.98. What is the difference between the Value added (% of GDP) of Cambodia in 2001 and the Value added (% of GDP) of Solomon Islands in 2002?
Offer a terse response. 11.3. What is the difference between the Value added (% of GDP) in Japan in 2001 and the Value added (% of GDP) in Senegal in 2002?
Your answer should be very brief. 4.04. What is the difference between the Value added (% of GDP) in Japan in 2001 and the Value added (% of GDP) in Solomon Islands in 2002?
Offer a terse response. 17.33. What is the difference between the Value added (% of GDP) of Senegal in 2001 and the Value added (% of GDP) of Solomon Islands in 2002?
Provide a succinct answer. 12.34. What is the difference between the Value added (% of GDP) of Cambodia in 2001 and the Value added (% of GDP) of Japan in 2003?
Provide a succinct answer. -5.1. What is the difference between the Value added (% of GDP) of Cambodia in 2001 and the Value added (% of GDP) of Senegal in 2003?
Provide a short and direct response. -0.93. What is the difference between the Value added (% of GDP) of Cambodia in 2001 and the Value added (% of GDP) of Solomon Islands in 2003?
Your answer should be compact. 12.7. What is the difference between the Value added (% of GDP) of Japan in 2001 and the Value added (% of GDP) of Senegal in 2003?
Your answer should be very brief. 5.09. What is the difference between the Value added (% of GDP) of Japan in 2001 and the Value added (% of GDP) of Solomon Islands in 2003?
Offer a terse response. 18.73. What is the difference between the Value added (% of GDP) in Senegal in 2001 and the Value added (% of GDP) in Solomon Islands in 2003?
Offer a terse response. 13.74. What is the difference between the Value added (% of GDP) of Cambodia in 2002 and the Value added (% of GDP) of Japan in 2003?
Make the answer very short. -2.98. What is the difference between the Value added (% of GDP) in Cambodia in 2002 and the Value added (% of GDP) in Senegal in 2003?
Make the answer very short. 1.2. What is the difference between the Value added (% of GDP) in Cambodia in 2002 and the Value added (% of GDP) in Solomon Islands in 2003?
Your answer should be compact. 14.83. What is the difference between the Value added (% of GDP) in Japan in 2002 and the Value added (% of GDP) in Senegal in 2003?
Ensure brevity in your answer.  4.26. What is the difference between the Value added (% of GDP) of Japan in 2002 and the Value added (% of GDP) of Solomon Islands in 2003?
Give a very brief answer. 17.89. What is the difference between the Value added (% of GDP) in Senegal in 2002 and the Value added (% of GDP) in Solomon Islands in 2003?
Your answer should be compact. 14.68. What is the average Value added (% of GDP) of Cambodia per year?
Ensure brevity in your answer.  20.96. What is the average Value added (% of GDP) of Japan per year?
Your response must be concise. 30.82. What is the average Value added (% of GDP) in Senegal per year?
Your answer should be very brief. 24.08. What is the average Value added (% of GDP) of Solomon Islands per year?
Ensure brevity in your answer.  13.33. In the year 1996, what is the difference between the Value added (% of GDP) of Cambodia and Value added (% of GDP) of Japan?
Offer a very short reply. -17.18. In the year 1996, what is the difference between the Value added (% of GDP) of Cambodia and Value added (% of GDP) of Senegal?
Offer a terse response. -8.63. In the year 1996, what is the difference between the Value added (% of GDP) of Cambodia and Value added (% of GDP) of Solomon Islands?
Make the answer very short. -0.08. In the year 1996, what is the difference between the Value added (% of GDP) of Japan and Value added (% of GDP) of Senegal?
Provide a short and direct response. 8.55. In the year 1996, what is the difference between the Value added (% of GDP) of Japan and Value added (% of GDP) of Solomon Islands?
Provide a succinct answer. 17.1. In the year 1996, what is the difference between the Value added (% of GDP) in Senegal and Value added (% of GDP) in Solomon Islands?
Give a very brief answer. 8.55. In the year 1997, what is the difference between the Value added (% of GDP) of Cambodia and Value added (% of GDP) of Japan?
Provide a succinct answer. -15.61. In the year 1997, what is the difference between the Value added (% of GDP) of Cambodia and Value added (% of GDP) of Senegal?
Offer a very short reply. -6.4. In the year 1997, what is the difference between the Value added (% of GDP) in Cambodia and Value added (% of GDP) in Solomon Islands?
Offer a terse response. 2.67. In the year 1997, what is the difference between the Value added (% of GDP) of Japan and Value added (% of GDP) of Senegal?
Make the answer very short. 9.21. In the year 1997, what is the difference between the Value added (% of GDP) in Japan and Value added (% of GDP) in Solomon Islands?
Make the answer very short. 18.27. In the year 1997, what is the difference between the Value added (% of GDP) of Senegal and Value added (% of GDP) of Solomon Islands?
Offer a very short reply. 9.07. In the year 1998, what is the difference between the Value added (% of GDP) of Cambodia and Value added (% of GDP) of Japan?
Make the answer very short. -14.43. In the year 1998, what is the difference between the Value added (% of GDP) of Cambodia and Value added (% of GDP) of Senegal?
Offer a terse response. -6.28. In the year 1998, what is the difference between the Value added (% of GDP) in Cambodia and Value added (% of GDP) in Solomon Islands?
Ensure brevity in your answer.  3.46. In the year 1998, what is the difference between the Value added (% of GDP) of Japan and Value added (% of GDP) of Senegal?
Your response must be concise. 8.15. In the year 1998, what is the difference between the Value added (% of GDP) of Japan and Value added (% of GDP) of Solomon Islands?
Make the answer very short. 17.89. In the year 1998, what is the difference between the Value added (% of GDP) in Senegal and Value added (% of GDP) in Solomon Islands?
Your answer should be very brief. 9.74. In the year 1999, what is the difference between the Value added (% of GDP) in Cambodia and Value added (% of GDP) in Japan?
Ensure brevity in your answer.  -12.21. In the year 1999, what is the difference between the Value added (% of GDP) of Cambodia and Value added (% of GDP) of Senegal?
Provide a succinct answer. -4.37. In the year 1999, what is the difference between the Value added (% of GDP) in Cambodia and Value added (% of GDP) in Solomon Islands?
Make the answer very short. 4.59. In the year 1999, what is the difference between the Value added (% of GDP) in Japan and Value added (% of GDP) in Senegal?
Your answer should be very brief. 7.84. In the year 1999, what is the difference between the Value added (% of GDP) in Japan and Value added (% of GDP) in Solomon Islands?
Offer a terse response. 16.8. In the year 1999, what is the difference between the Value added (% of GDP) of Senegal and Value added (% of GDP) of Solomon Islands?
Your answer should be very brief. 8.96. In the year 2000, what is the difference between the Value added (% of GDP) of Cambodia and Value added (% of GDP) of Japan?
Your answer should be compact. -8.04. In the year 2000, what is the difference between the Value added (% of GDP) in Cambodia and Value added (% of GDP) in Senegal?
Keep it short and to the point. -0.21. In the year 2000, what is the difference between the Value added (% of GDP) of Cambodia and Value added (% of GDP) of Solomon Islands?
Keep it short and to the point. 10.31. In the year 2000, what is the difference between the Value added (% of GDP) of Japan and Value added (% of GDP) of Senegal?
Keep it short and to the point. 7.83. In the year 2000, what is the difference between the Value added (% of GDP) in Japan and Value added (% of GDP) in Solomon Islands?
Give a very brief answer. 18.35. In the year 2000, what is the difference between the Value added (% of GDP) of Senegal and Value added (% of GDP) of Solomon Islands?
Keep it short and to the point. 10.51. In the year 2001, what is the difference between the Value added (% of GDP) in Cambodia and Value added (% of GDP) in Japan?
Your response must be concise. -6.02. In the year 2001, what is the difference between the Value added (% of GDP) of Cambodia and Value added (% of GDP) of Senegal?
Your response must be concise. -1.04. In the year 2001, what is the difference between the Value added (% of GDP) in Cambodia and Value added (% of GDP) in Solomon Islands?
Your answer should be very brief. 11.19. In the year 2001, what is the difference between the Value added (% of GDP) of Japan and Value added (% of GDP) of Senegal?
Ensure brevity in your answer.  4.99. In the year 2001, what is the difference between the Value added (% of GDP) in Japan and Value added (% of GDP) in Solomon Islands?
Your answer should be compact. 17.22. In the year 2001, what is the difference between the Value added (% of GDP) of Senegal and Value added (% of GDP) of Solomon Islands?
Your answer should be compact. 12.23. In the year 2002, what is the difference between the Value added (% of GDP) in Cambodia and Value added (% of GDP) in Japan?
Your response must be concise. -3.06. In the year 2002, what is the difference between the Value added (% of GDP) in Cambodia and Value added (% of GDP) in Senegal?
Your answer should be compact. 0.14. In the year 2002, what is the difference between the Value added (% of GDP) of Cambodia and Value added (% of GDP) of Solomon Islands?
Keep it short and to the point. 13.43. In the year 2002, what is the difference between the Value added (% of GDP) of Japan and Value added (% of GDP) of Senegal?
Ensure brevity in your answer.  3.21. In the year 2002, what is the difference between the Value added (% of GDP) in Japan and Value added (% of GDP) in Solomon Islands?
Keep it short and to the point. 16.49. In the year 2002, what is the difference between the Value added (% of GDP) of Senegal and Value added (% of GDP) of Solomon Islands?
Ensure brevity in your answer.  13.28. In the year 2003, what is the difference between the Value added (% of GDP) in Cambodia and Value added (% of GDP) in Japan?
Make the answer very short. -2.33. In the year 2003, what is the difference between the Value added (% of GDP) of Cambodia and Value added (% of GDP) of Senegal?
Make the answer very short. 1.84. In the year 2003, what is the difference between the Value added (% of GDP) of Cambodia and Value added (% of GDP) of Solomon Islands?
Offer a very short reply. 15.48. In the year 2003, what is the difference between the Value added (% of GDP) in Japan and Value added (% of GDP) in Senegal?
Make the answer very short. 4.17. In the year 2003, what is the difference between the Value added (% of GDP) in Japan and Value added (% of GDP) in Solomon Islands?
Make the answer very short. 17.81. In the year 2003, what is the difference between the Value added (% of GDP) of Senegal and Value added (% of GDP) of Solomon Islands?
Your answer should be compact. 13.63. What is the ratio of the Value added (% of GDP) in Cambodia in 1996 to that in 1997?
Your answer should be compact. 0.92. What is the ratio of the Value added (% of GDP) of Senegal in 1996 to that in 1997?
Your answer should be very brief. 1.04. What is the ratio of the Value added (% of GDP) in Solomon Islands in 1996 to that in 1997?
Your answer should be compact. 1.1. What is the ratio of the Value added (% of GDP) of Cambodia in 1996 to that in 1998?
Offer a terse response. 0.9. What is the ratio of the Value added (% of GDP) in Japan in 1996 to that in 1998?
Ensure brevity in your answer.  1.03. What is the ratio of the Value added (% of GDP) in Senegal in 1996 to that in 1998?
Ensure brevity in your answer.  1.03. What is the ratio of the Value added (% of GDP) in Solomon Islands in 1996 to that in 1998?
Offer a very short reply. 1.13. What is the ratio of the Value added (% of GDP) in Cambodia in 1996 to that in 1999?
Your answer should be very brief. 0.82. What is the ratio of the Value added (% of GDP) in Senegal in 1996 to that in 1999?
Your answer should be very brief. 1.04. What is the ratio of the Value added (% of GDP) in Solomon Islands in 1996 to that in 1999?
Your answer should be compact. 1.09. What is the ratio of the Value added (% of GDP) in Cambodia in 1996 to that in 2000?
Give a very brief answer. 0.68. What is the ratio of the Value added (% of GDP) of Japan in 1996 to that in 2000?
Your answer should be very brief. 1.06. What is the ratio of the Value added (% of GDP) in Senegal in 1996 to that in 2000?
Provide a succinct answer. 1.05. What is the ratio of the Value added (% of GDP) in Solomon Islands in 1996 to that in 2000?
Ensure brevity in your answer.  1.24. What is the ratio of the Value added (% of GDP) in Cambodia in 1996 to that in 2001?
Your response must be concise. 0.67. What is the ratio of the Value added (% of GDP) of Japan in 1996 to that in 2001?
Make the answer very short. 1.11. What is the ratio of the Value added (% of GDP) in Solomon Islands in 1996 to that in 2001?
Give a very brief answer. 1.28. What is the ratio of the Value added (% of GDP) of Cambodia in 1996 to that in 2002?
Provide a short and direct response. 0.61. What is the ratio of the Value added (% of GDP) of Japan in 1996 to that in 2002?
Ensure brevity in your answer.  1.15. What is the ratio of the Value added (% of GDP) in Senegal in 1996 to that in 2002?
Give a very brief answer. 0.96. What is the ratio of the Value added (% of GDP) in Solomon Islands in 1996 to that in 2002?
Offer a terse response. 1.3. What is the ratio of the Value added (% of GDP) of Cambodia in 1996 to that in 2003?
Offer a very short reply. 0.6. What is the ratio of the Value added (% of GDP) in Japan in 1996 to that in 2003?
Offer a terse response. 1.15. What is the ratio of the Value added (% of GDP) of Solomon Islands in 1996 to that in 2003?
Make the answer very short. 1.46. What is the ratio of the Value added (% of GDP) in Cambodia in 1997 to that in 1998?
Provide a succinct answer. 0.98. What is the ratio of the Value added (% of GDP) of Japan in 1997 to that in 1998?
Your response must be concise. 1.03. What is the ratio of the Value added (% of GDP) of Senegal in 1997 to that in 1998?
Make the answer very short. 0.99. What is the ratio of the Value added (% of GDP) of Solomon Islands in 1997 to that in 1998?
Your response must be concise. 1.03. What is the ratio of the Value added (% of GDP) of Cambodia in 1997 to that in 1999?
Keep it short and to the point. 0.89. What is the ratio of the Value added (% of GDP) in Japan in 1997 to that in 1999?
Give a very brief answer. 1.04. What is the ratio of the Value added (% of GDP) in Senegal in 1997 to that in 1999?
Provide a succinct answer. 1. What is the ratio of the Value added (% of GDP) in Cambodia in 1997 to that in 2000?
Keep it short and to the point. 0.74. What is the ratio of the Value added (% of GDP) in Japan in 1997 to that in 2000?
Provide a short and direct response. 1.05. What is the ratio of the Value added (% of GDP) of Senegal in 1997 to that in 2000?
Your answer should be very brief. 1.01. What is the ratio of the Value added (% of GDP) of Solomon Islands in 1997 to that in 2000?
Provide a short and direct response. 1.13. What is the ratio of the Value added (% of GDP) in Cambodia in 1997 to that in 2001?
Ensure brevity in your answer.  0.73. What is the ratio of the Value added (% of GDP) of Japan in 1997 to that in 2001?
Your answer should be very brief. 1.11. What is the ratio of the Value added (% of GDP) in Senegal in 1997 to that in 2001?
Ensure brevity in your answer.  0.96. What is the ratio of the Value added (% of GDP) in Solomon Islands in 1997 to that in 2001?
Make the answer very short. 1.17. What is the ratio of the Value added (% of GDP) in Cambodia in 1997 to that in 2002?
Your answer should be compact. 0.67. What is the ratio of the Value added (% of GDP) of Japan in 1997 to that in 2002?
Make the answer very short. 1.14. What is the ratio of the Value added (% of GDP) in Senegal in 1997 to that in 2002?
Your response must be concise. 0.92. What is the ratio of the Value added (% of GDP) of Solomon Islands in 1997 to that in 2002?
Make the answer very short. 1.18. What is the ratio of the Value added (% of GDP) of Cambodia in 1997 to that in 2003?
Your answer should be very brief. 0.65. What is the ratio of the Value added (% of GDP) of Japan in 1997 to that in 2003?
Give a very brief answer. 1.14. What is the ratio of the Value added (% of GDP) in Senegal in 1997 to that in 2003?
Your response must be concise. 0.96. What is the ratio of the Value added (% of GDP) in Solomon Islands in 1997 to that in 2003?
Provide a succinct answer. 1.34. What is the ratio of the Value added (% of GDP) of Cambodia in 1998 to that in 1999?
Provide a succinct answer. 0.91. What is the ratio of the Value added (% of GDP) in Japan in 1998 to that in 1999?
Your answer should be very brief. 1.02. What is the ratio of the Value added (% of GDP) in Senegal in 1998 to that in 1999?
Offer a very short reply. 1.01. What is the ratio of the Value added (% of GDP) of Solomon Islands in 1998 to that in 1999?
Keep it short and to the point. 0.96. What is the ratio of the Value added (% of GDP) in Cambodia in 1998 to that in 2000?
Your answer should be very brief. 0.76. What is the ratio of the Value added (% of GDP) in Japan in 1998 to that in 2000?
Make the answer very short. 1.02. What is the ratio of the Value added (% of GDP) of Senegal in 1998 to that in 2000?
Provide a succinct answer. 1.02. What is the ratio of the Value added (% of GDP) of Solomon Islands in 1998 to that in 2000?
Keep it short and to the point. 1.1. What is the ratio of the Value added (% of GDP) in Cambodia in 1998 to that in 2001?
Give a very brief answer. 0.74. What is the ratio of the Value added (% of GDP) in Japan in 1998 to that in 2001?
Your response must be concise. 1.08. What is the ratio of the Value added (% of GDP) in Senegal in 1998 to that in 2001?
Provide a succinct answer. 0.97. What is the ratio of the Value added (% of GDP) of Solomon Islands in 1998 to that in 2001?
Provide a succinct answer. 1.13. What is the ratio of the Value added (% of GDP) in Cambodia in 1998 to that in 2002?
Your answer should be very brief. 0.68. What is the ratio of the Value added (% of GDP) of Japan in 1998 to that in 2002?
Ensure brevity in your answer.  1.11. What is the ratio of the Value added (% of GDP) in Senegal in 1998 to that in 2002?
Your response must be concise. 0.93. What is the ratio of the Value added (% of GDP) of Solomon Islands in 1998 to that in 2002?
Provide a succinct answer. 1.15. What is the ratio of the Value added (% of GDP) in Cambodia in 1998 to that in 2003?
Keep it short and to the point. 0.66. What is the ratio of the Value added (% of GDP) of Japan in 1998 to that in 2003?
Your response must be concise. 1.11. What is the ratio of the Value added (% of GDP) in Senegal in 1998 to that in 2003?
Your answer should be very brief. 0.97. What is the ratio of the Value added (% of GDP) in Solomon Islands in 1998 to that in 2003?
Your answer should be very brief. 1.29. What is the ratio of the Value added (% of GDP) in Cambodia in 1999 to that in 2000?
Your answer should be compact. 0.83. What is the ratio of the Value added (% of GDP) in Japan in 1999 to that in 2000?
Provide a succinct answer. 1.01. What is the ratio of the Value added (% of GDP) of Senegal in 1999 to that in 2000?
Make the answer very short. 1.01. What is the ratio of the Value added (% of GDP) of Solomon Islands in 1999 to that in 2000?
Your answer should be compact. 1.14. What is the ratio of the Value added (% of GDP) of Cambodia in 1999 to that in 2001?
Keep it short and to the point. 0.81. What is the ratio of the Value added (% of GDP) in Japan in 1999 to that in 2001?
Give a very brief answer. 1.06. What is the ratio of the Value added (% of GDP) of Senegal in 1999 to that in 2001?
Ensure brevity in your answer.  0.96. What is the ratio of the Value added (% of GDP) in Solomon Islands in 1999 to that in 2001?
Provide a succinct answer. 1.18. What is the ratio of the Value added (% of GDP) in Cambodia in 1999 to that in 2002?
Your answer should be very brief. 0.75. What is the ratio of the Value added (% of GDP) in Japan in 1999 to that in 2002?
Provide a short and direct response. 1.09. What is the ratio of the Value added (% of GDP) of Senegal in 1999 to that in 2002?
Provide a succinct answer. 0.92. What is the ratio of the Value added (% of GDP) of Solomon Islands in 1999 to that in 2002?
Provide a short and direct response. 1.19. What is the ratio of the Value added (% of GDP) of Cambodia in 1999 to that in 2003?
Make the answer very short. 0.73. What is the ratio of the Value added (% of GDP) in Japan in 1999 to that in 2003?
Offer a very short reply. 1.1. What is the ratio of the Value added (% of GDP) of Senegal in 1999 to that in 2003?
Your response must be concise. 0.96. What is the ratio of the Value added (% of GDP) of Solomon Islands in 1999 to that in 2003?
Your response must be concise. 1.35. What is the ratio of the Value added (% of GDP) of Cambodia in 2000 to that in 2001?
Offer a terse response. 0.98. What is the ratio of the Value added (% of GDP) of Japan in 2000 to that in 2001?
Offer a very short reply. 1.05. What is the ratio of the Value added (% of GDP) in Senegal in 2000 to that in 2001?
Provide a succinct answer. 0.95. What is the ratio of the Value added (% of GDP) of Solomon Islands in 2000 to that in 2001?
Your answer should be very brief. 1.03. What is the ratio of the Value added (% of GDP) in Cambodia in 2000 to that in 2002?
Your answer should be very brief. 0.9. What is the ratio of the Value added (% of GDP) of Japan in 2000 to that in 2002?
Offer a terse response. 1.08. What is the ratio of the Value added (% of GDP) of Senegal in 2000 to that in 2002?
Provide a short and direct response. 0.91. What is the ratio of the Value added (% of GDP) in Solomon Islands in 2000 to that in 2002?
Give a very brief answer. 1.04. What is the ratio of the Value added (% of GDP) of Cambodia in 2000 to that in 2003?
Ensure brevity in your answer.  0.88. What is the ratio of the Value added (% of GDP) in Japan in 2000 to that in 2003?
Give a very brief answer. 1.09. What is the ratio of the Value added (% of GDP) of Senegal in 2000 to that in 2003?
Your answer should be compact. 0.95. What is the ratio of the Value added (% of GDP) in Solomon Islands in 2000 to that in 2003?
Offer a very short reply. 1.18. What is the ratio of the Value added (% of GDP) in Cambodia in 2001 to that in 2002?
Ensure brevity in your answer.  0.92. What is the ratio of the Value added (% of GDP) of Japan in 2001 to that in 2002?
Give a very brief answer. 1.03. What is the ratio of the Value added (% of GDP) of Senegal in 2001 to that in 2002?
Make the answer very short. 0.96. What is the ratio of the Value added (% of GDP) in Solomon Islands in 2001 to that in 2002?
Make the answer very short. 1.01. What is the ratio of the Value added (% of GDP) of Cambodia in 2001 to that in 2003?
Make the answer very short. 0.89. What is the ratio of the Value added (% of GDP) in Japan in 2001 to that in 2003?
Your response must be concise. 1.03. What is the ratio of the Value added (% of GDP) of Senegal in 2001 to that in 2003?
Ensure brevity in your answer.  1. What is the ratio of the Value added (% of GDP) of Solomon Islands in 2001 to that in 2003?
Ensure brevity in your answer.  1.14. What is the ratio of the Value added (% of GDP) of Cambodia in 2002 to that in 2003?
Make the answer very short. 0.98. What is the ratio of the Value added (% of GDP) of Japan in 2002 to that in 2003?
Your response must be concise. 1. What is the ratio of the Value added (% of GDP) of Senegal in 2002 to that in 2003?
Provide a succinct answer. 1.04. What is the ratio of the Value added (% of GDP) of Solomon Islands in 2002 to that in 2003?
Your answer should be very brief. 1.13. What is the difference between the highest and the second highest Value added (% of GDP) of Cambodia?
Provide a short and direct response. 0.65. What is the difference between the highest and the second highest Value added (% of GDP) in Japan?
Make the answer very short. 0.2. What is the difference between the highest and the second highest Value added (% of GDP) in Senegal?
Provide a succinct answer. 0.94. What is the difference between the highest and the second highest Value added (% of GDP) of Solomon Islands?
Keep it short and to the point. 1.27. What is the difference between the highest and the lowest Value added (% of GDP) in Cambodia?
Your answer should be very brief. 10.55. What is the difference between the highest and the lowest Value added (% of GDP) of Japan?
Offer a very short reply. 4.3. What is the difference between the highest and the lowest Value added (% of GDP) in Senegal?
Keep it short and to the point. 2.24. What is the difference between the highest and the lowest Value added (% of GDP) of Solomon Islands?
Your answer should be compact. 5. 